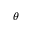Convert formula to latex. <formula><loc_0><loc_0><loc_500><loc_500>\theta</formula> 